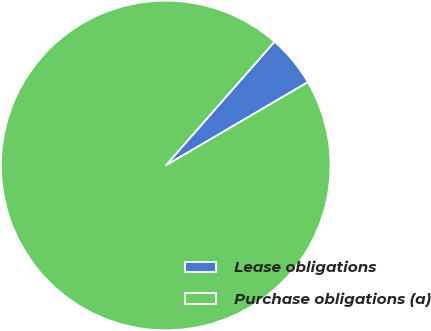Convert chart. <chart><loc_0><loc_0><loc_500><loc_500><pie_chart><fcel>Lease obligations<fcel>Purchase obligations (a)<nl><fcel>5.09%<fcel>94.91%<nl></chart> 